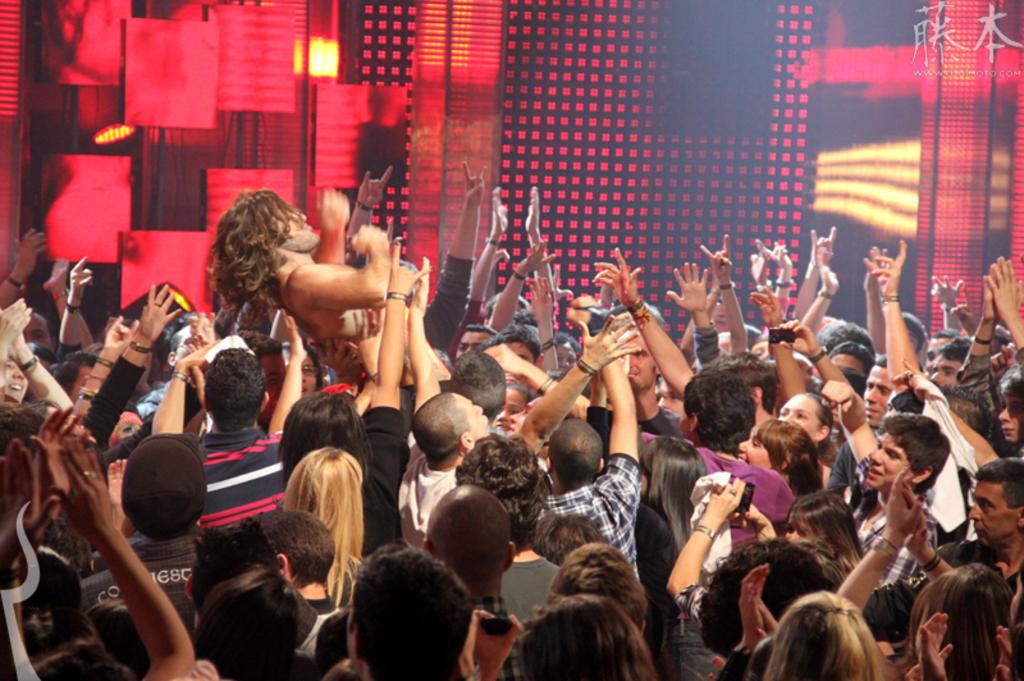How many people are in the group shown in the image? There is a group of people in the image, but the exact number cannot be determined from the provided facts. What are the people in the group doing? Some people in the group are lifting another person. What can be seen in the background of the image? There are screens and lights in the background of the image. What type of popcorn is being served on the grass in the image? There is no popcorn or grass present in the image. 